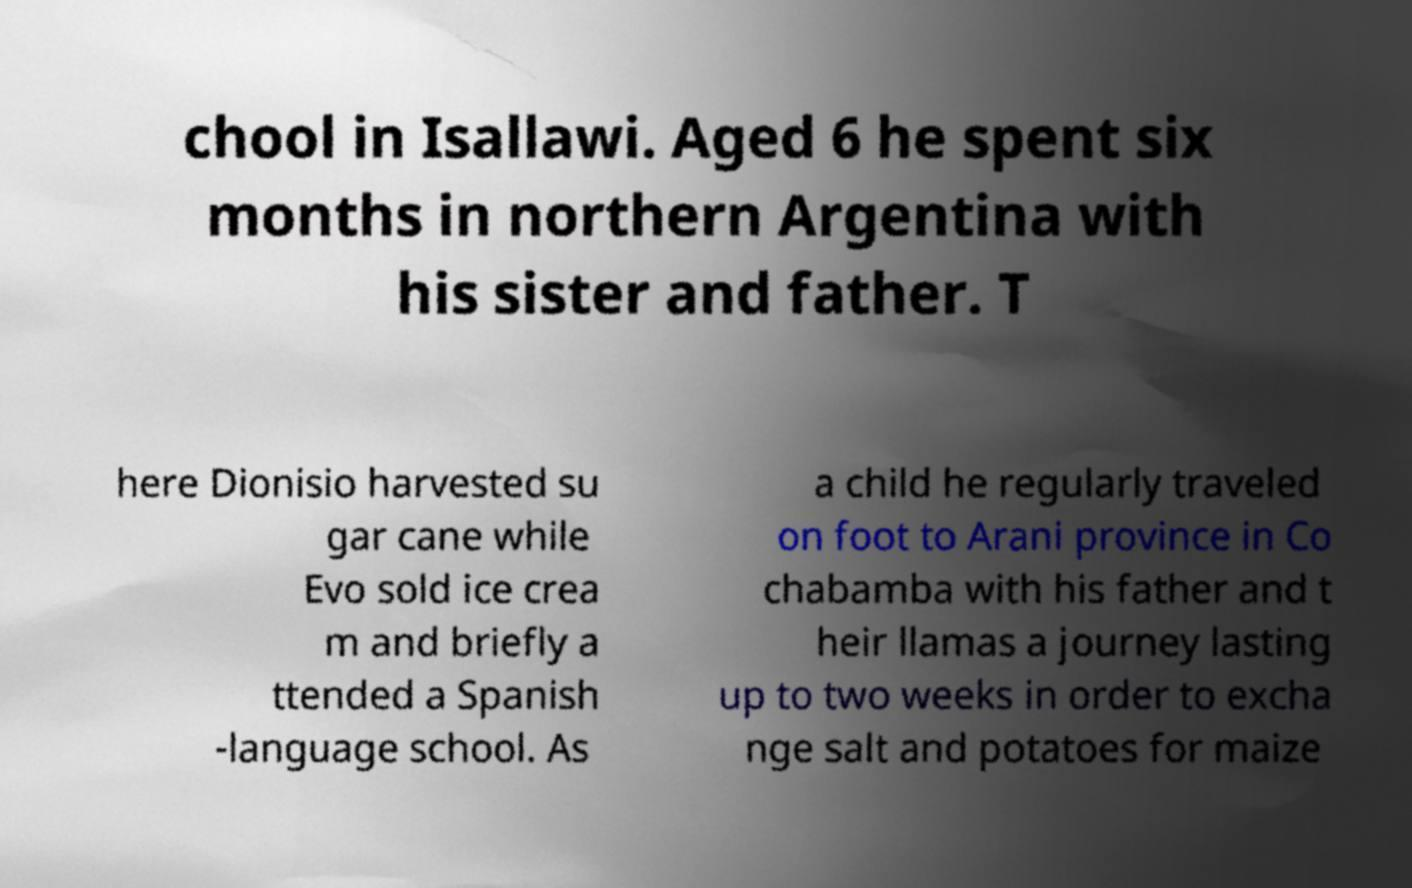Can you accurately transcribe the text from the provided image for me? chool in Isallawi. Aged 6 he spent six months in northern Argentina with his sister and father. T here Dionisio harvested su gar cane while Evo sold ice crea m and briefly a ttended a Spanish -language school. As a child he regularly traveled on foot to Arani province in Co chabamba with his father and t heir llamas a journey lasting up to two weeks in order to excha nge salt and potatoes for maize 